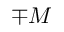<formula> <loc_0><loc_0><loc_500><loc_500>\mp M</formula> 